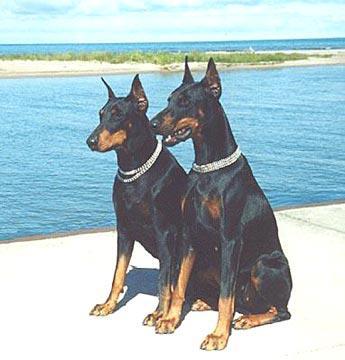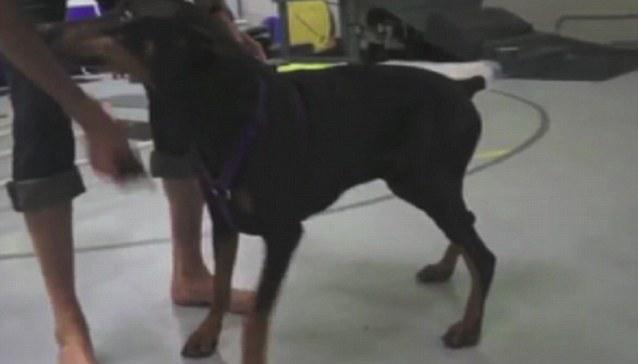The first image is the image on the left, the second image is the image on the right. For the images shown, is this caption "There are more dogs in the image on the left." true? Answer yes or no. Yes. 